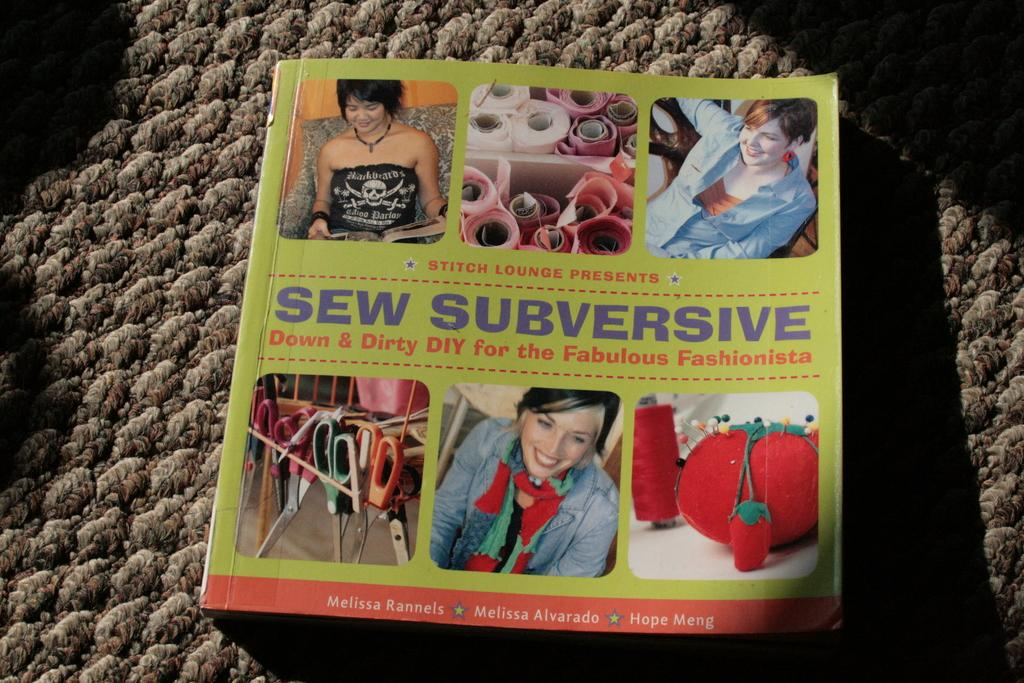What is placed on the carpet in the image? There is a book on a carpet in the image. What can be found on the book? There is text on the book. What type of objects are depicted in the images within the image? There are images of scissors, women, and wool in the image. Where is the tub located in the image? There is no tub present in the image. What type of bears can be seen interacting with the scissors in the image? There are no bears present in the image, and the scissors are depicted in images, not interacting with any animals. 